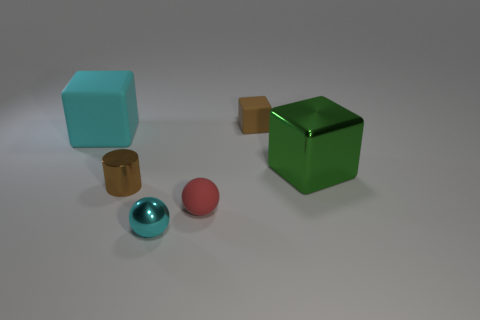Add 3 small cyan rubber objects. How many objects exist? 9 Subtract all spheres. How many objects are left? 4 Subtract all small shiny things. Subtract all tiny brown rubber blocks. How many objects are left? 3 Add 6 green cubes. How many green cubes are left? 7 Add 4 tiny red matte balls. How many tiny red matte balls exist? 5 Subtract 1 cyan spheres. How many objects are left? 5 